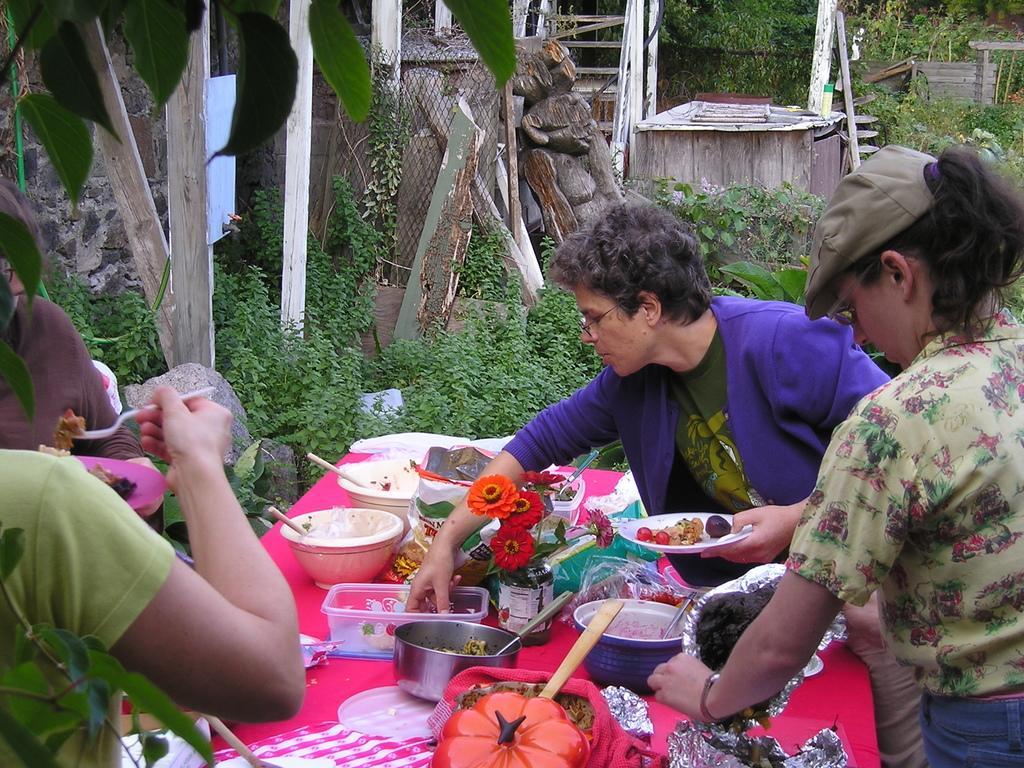Could you give a brief overview of what you see in this image? In the image we can see there are many people around, they are wearing clothes and some of them are wearing spectacles and a cap. This is a table, on the table there is a container, spoon, box, plate, food on a plate, flowers and a plastic cover. This is a grass, wooden pole, leaves and a wooden log. 